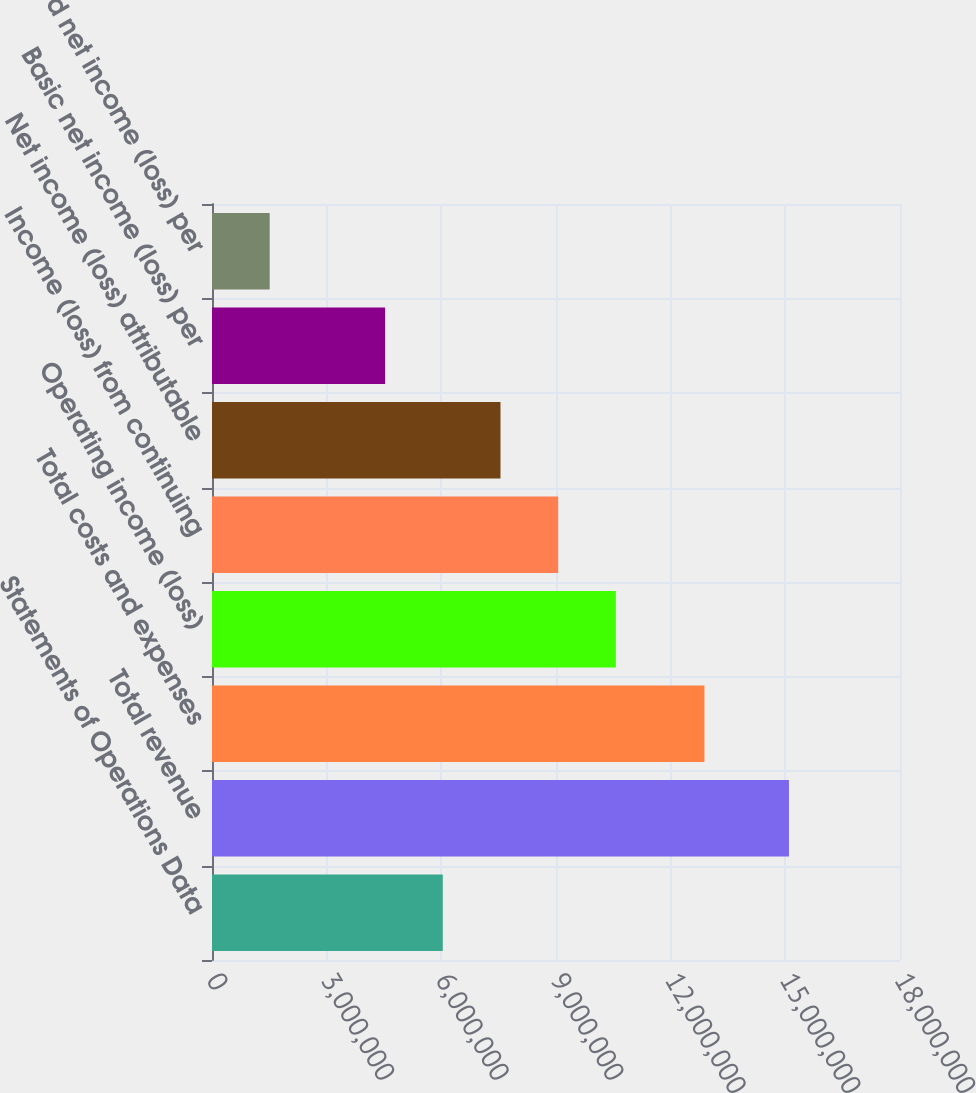Convert chart to OTSL. <chart><loc_0><loc_0><loc_500><loc_500><bar_chart><fcel>Statements of Operations Data<fcel>Total revenue<fcel>Total costs and expenses<fcel>Operating income (loss)<fcel>Income (loss) from continuing<fcel>Net income (loss) attributable<fcel>Basic net income (loss) per<fcel>Diluted net income (loss) per<nl><fcel>6.03783e+06<fcel>1.50946e+07<fcel>1.28835e+07<fcel>1.05662e+07<fcel>9.05674e+06<fcel>7.54728e+06<fcel>4.52837e+06<fcel>1.50946e+06<nl></chart> 